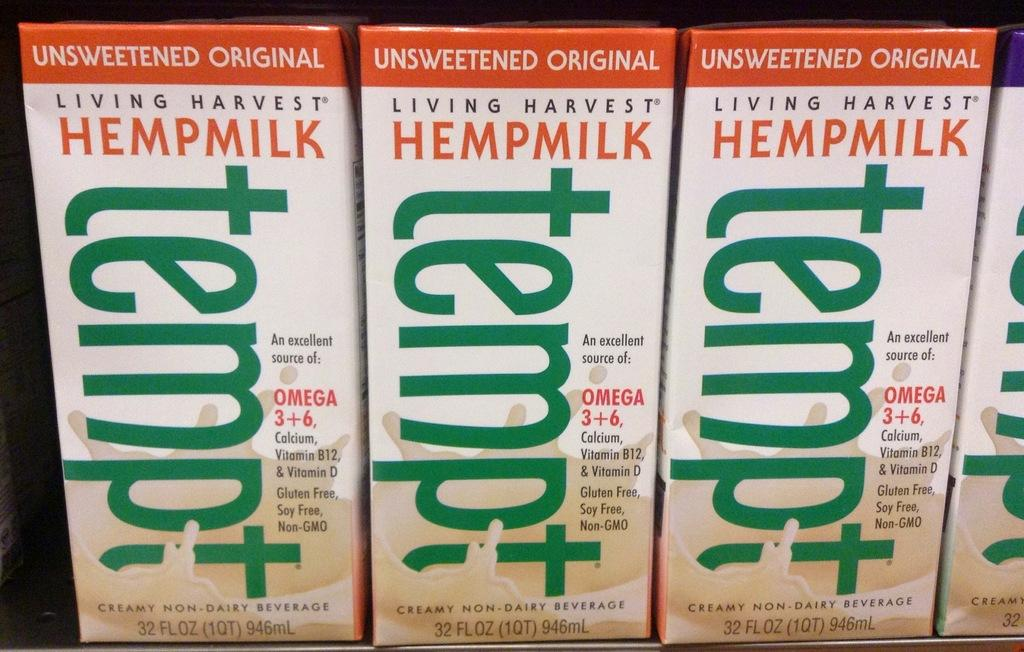<image>
Render a clear and concise summary of the photo. Box of Tempt Unsweetend original living harvest HempMilk. 